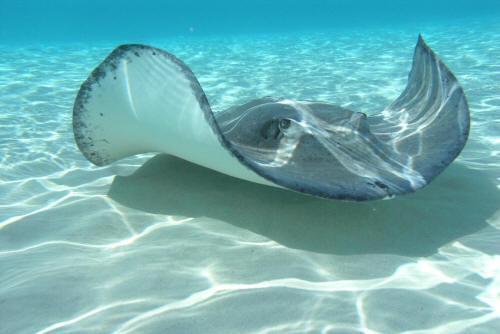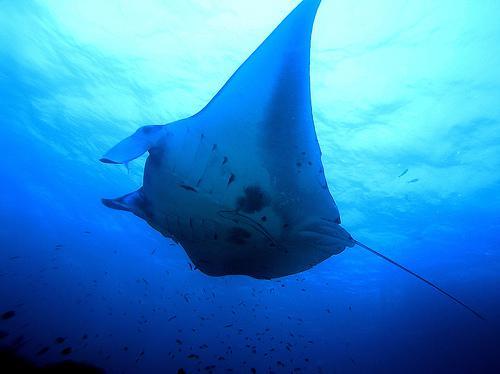The first image is the image on the left, the second image is the image on the right. Evaluate the accuracy of this statement regarding the images: "There are two manta rays in total.". Is it true? Answer yes or no. Yes. The first image is the image on the left, the second image is the image on the right. Given the left and right images, does the statement "An image contains exactly two stingray swimming in blue water with light shining in the scene." hold true? Answer yes or no. No. 